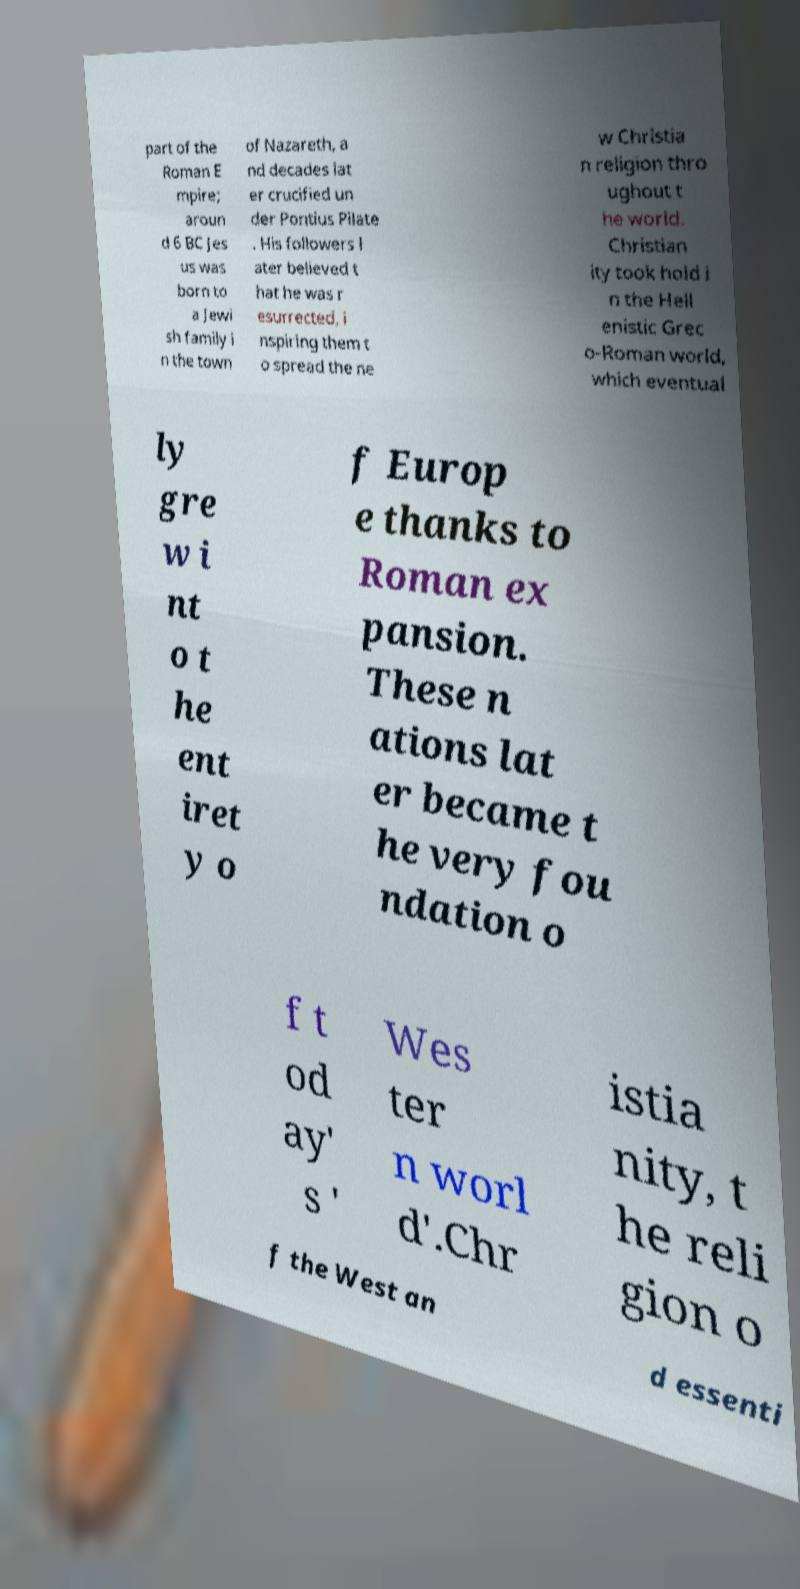For documentation purposes, I need the text within this image transcribed. Could you provide that? part of the Roman E mpire; aroun d 6 BC Jes us was born to a Jewi sh family i n the town of Nazareth, a nd decades lat er crucified un der Pontius Pilate . His followers l ater believed t hat he was r esurrected, i nspiring them t o spread the ne w Christia n religion thro ughout t he world. Christian ity took hold i n the Hell enistic Grec o-Roman world, which eventual ly gre w i nt o t he ent iret y o f Europ e thanks to Roman ex pansion. These n ations lat er became t he very fou ndation o f t od ay' s ' Wes ter n worl d'.Chr istia nity, t he reli gion o f the West an d essenti 